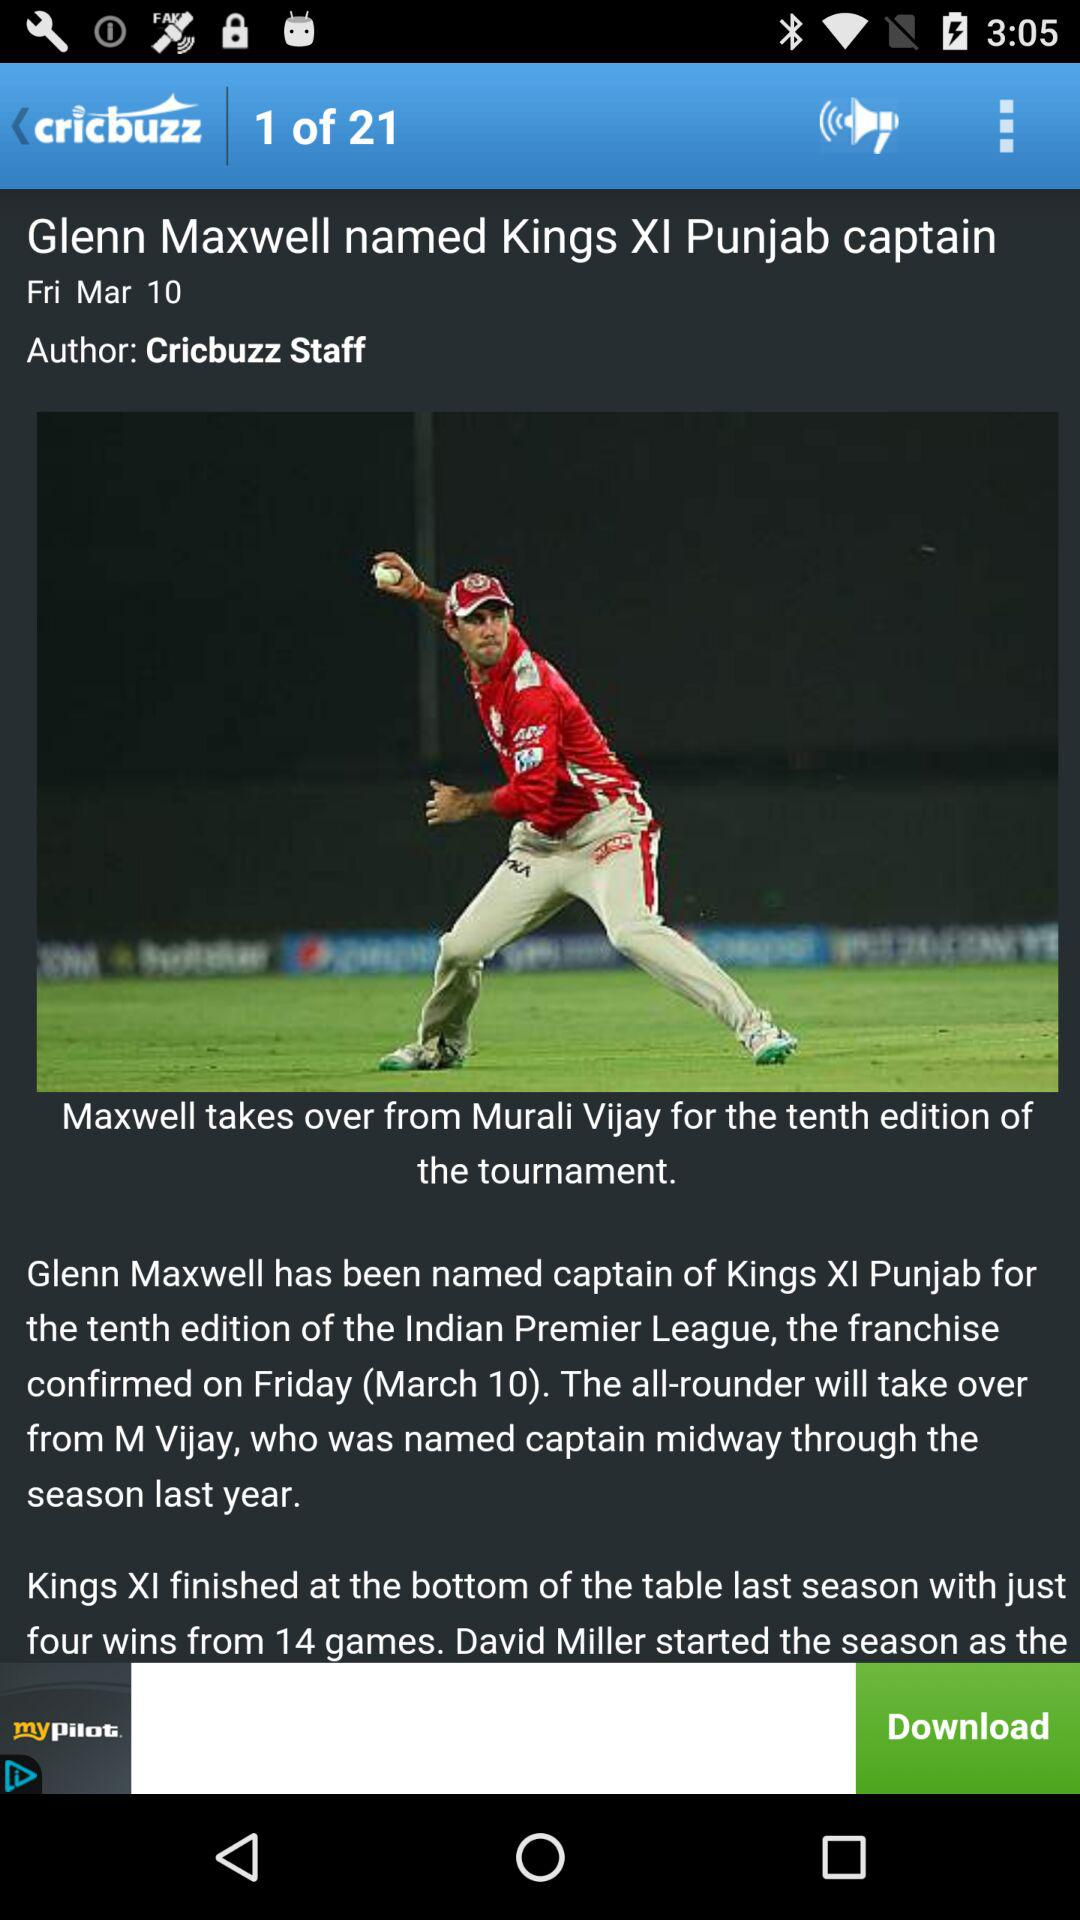Who is the author of the news? The author of the news is Cricbuzz Staff. 